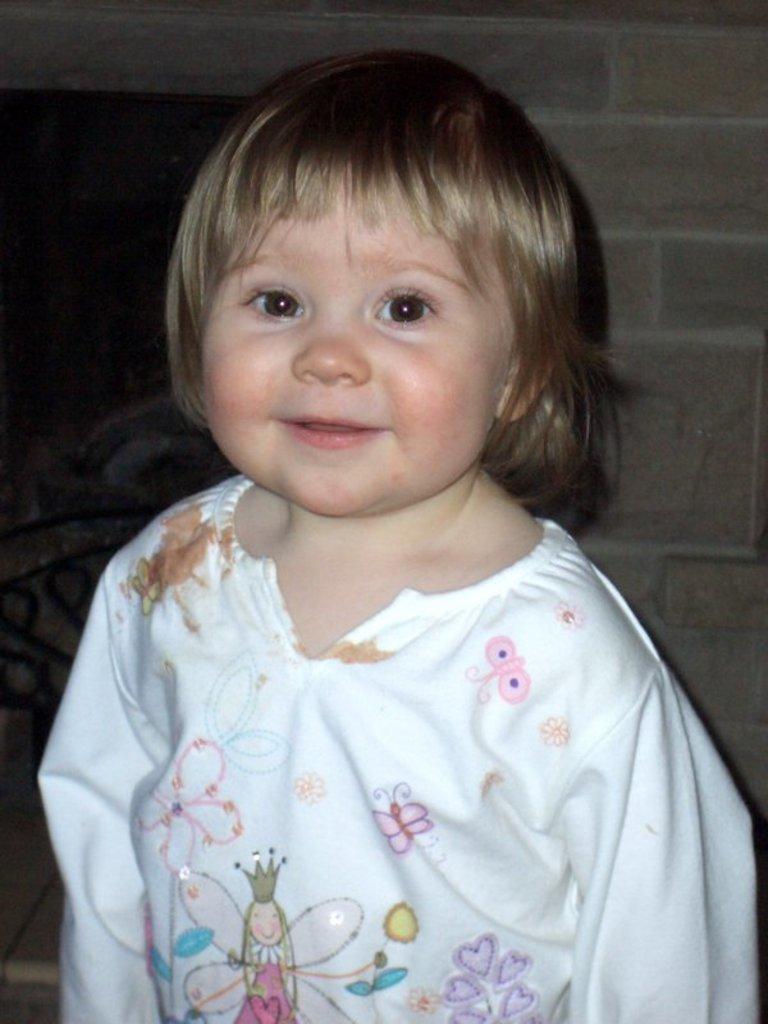In one or two sentences, can you explain what this image depicts? In this picture we can see a girl. There is a wall in the background. 